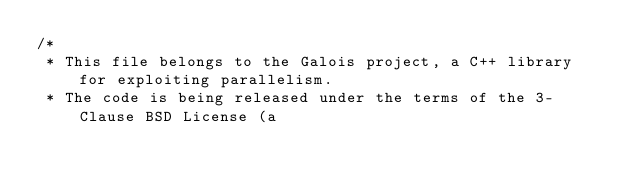<code> <loc_0><loc_0><loc_500><loc_500><_Cuda_>/*
 * This file belongs to the Galois project, a C++ library for exploiting parallelism.
 * The code is being released under the terms of the 3-Clause BSD License (a</code> 